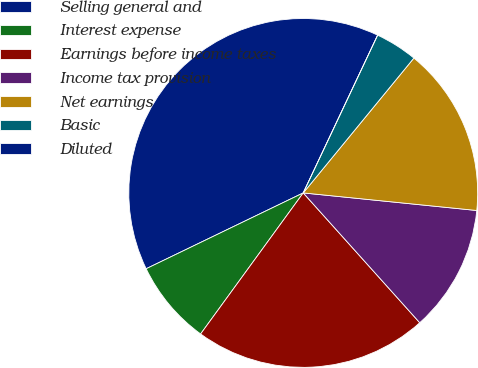Convert chart to OTSL. <chart><loc_0><loc_0><loc_500><loc_500><pie_chart><fcel>Selling general and<fcel>Interest expense<fcel>Earnings before income taxes<fcel>Income tax provision<fcel>Net earnings<fcel>Basic<fcel>Diluted<nl><fcel>39.17%<fcel>7.83%<fcel>21.65%<fcel>11.75%<fcel>15.67%<fcel>3.92%<fcel>0.0%<nl></chart> 